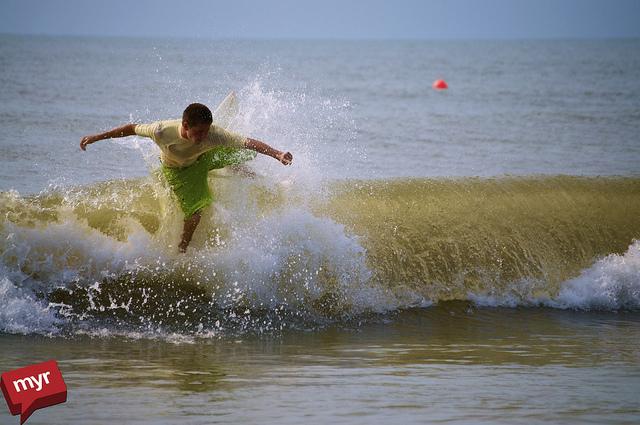Is this person about to fall?
Quick response, please. Yes. Is the person wearing a wetsuit?
Be succinct. No. Is this person at the beach?
Be succinct. Yes. What color is the water?
Concise answer only. Yellow. 